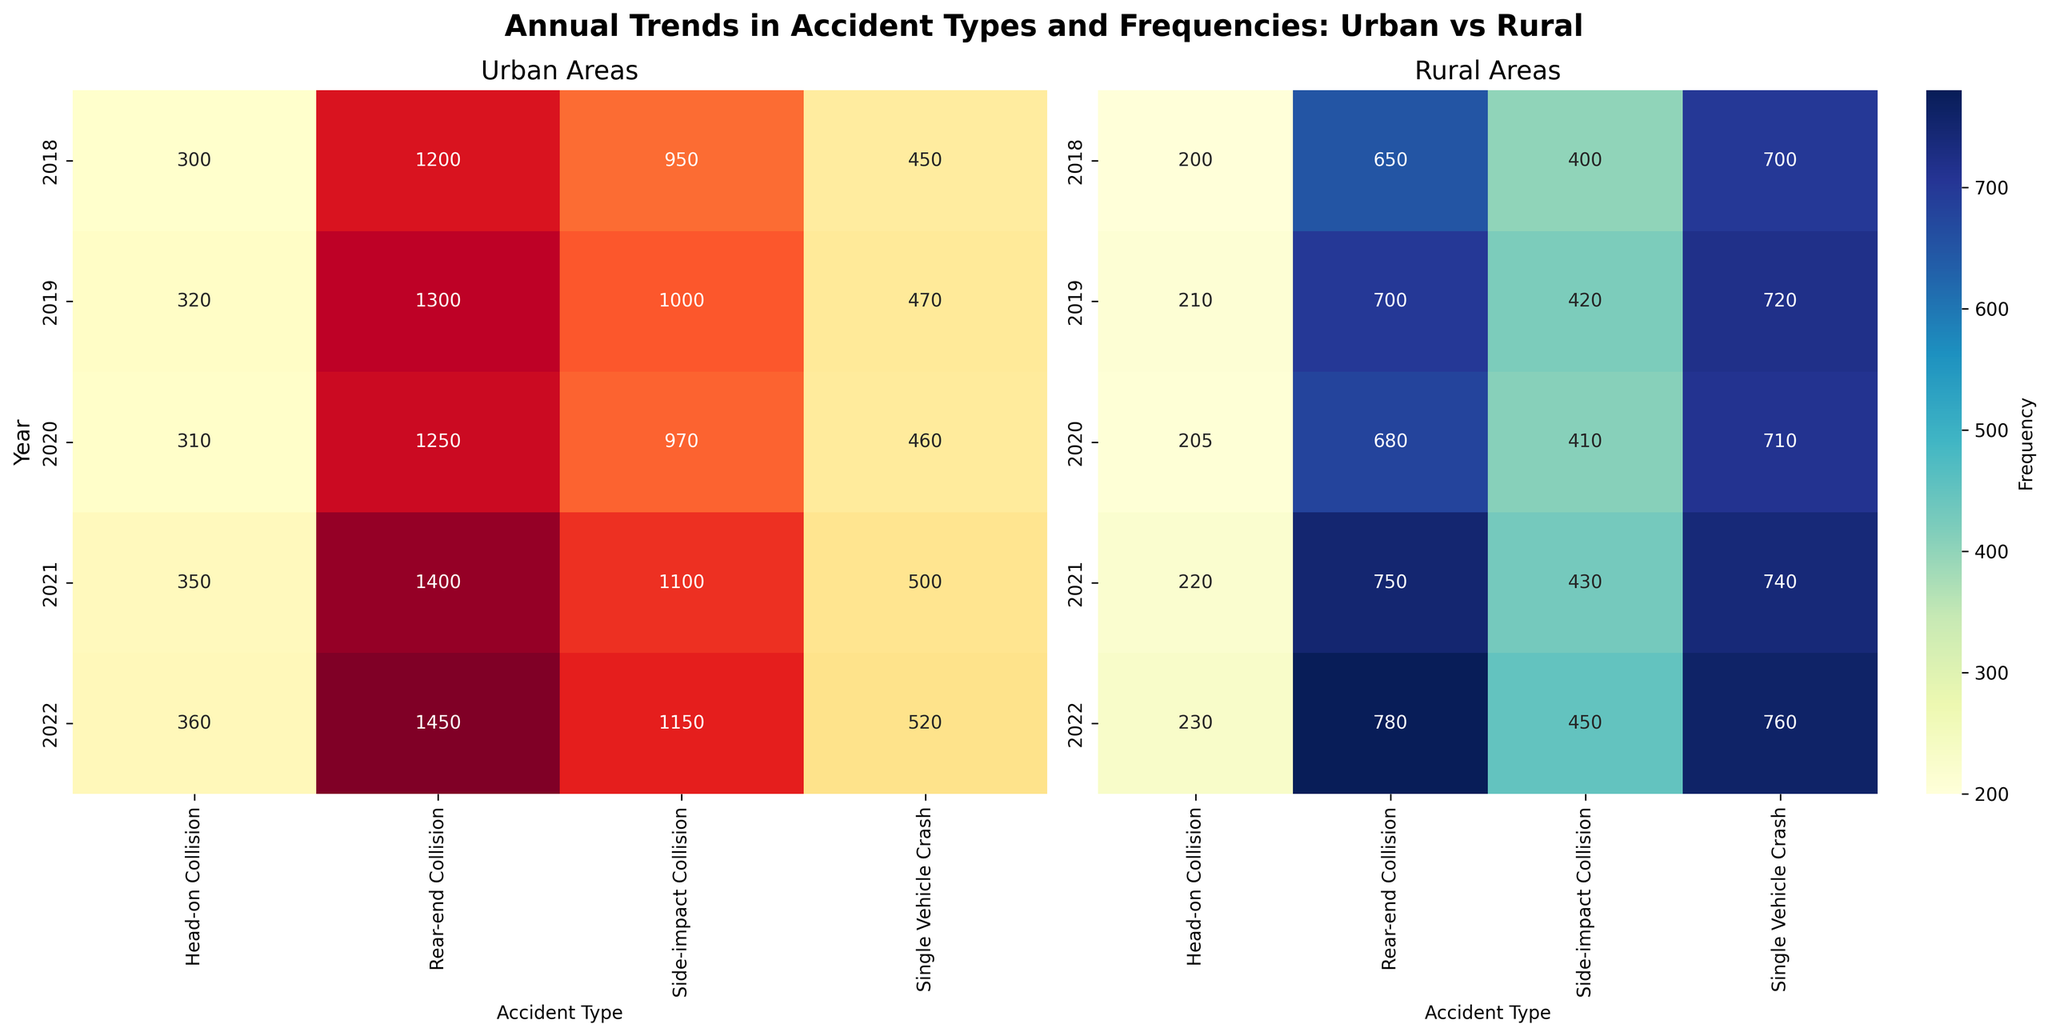How many types of accidents are reported for the year 2018 in rural areas? Look at the 'Rural Areas' heatmap under the year 2018, then count the number of accident types listed.
Answer: 4 Which type of accident had the highest frequency in urban areas in 2022? Look at the 'Urban Areas' heatmap under the year 2022 and find the highest value. The corresponding accident type is 'Rear-end Collision', with a frequency of 1450.
Answer: Rear-end Collision What is the total frequency of all accidents in rural areas in 2021? Check the 'Rural Areas' heatmap under the year 2021, then sum the frequency values for all accident types: 750 + 430 + 220 + 740 = 2140.
Answer: 2140 How does the frequency of side-impact collisions in urban areas compare between 2020 and 2022? Check the frequency of side-impact collisions for the 'Urban Areas' heatmap in the years 2020 and 2022. For 2020, it is 970, and for 2022, it is 1150.
Answer: Increased Which collision type experienced the least frequency in both urban and rural areas in 2020? Look at both heatmaps for 2020 and identify the lowest value for each. In urban areas, it is 'Head-on Collision' with 310, and in rural areas, it's also 'Head-on Collision' with 205. Hence, 'Head-on Collision' is the least frequent.
Answer: Head-on Collision Is there a trend in the frequency of single-vehicle crashes in rural areas from 2018 to 2022? Assess the 'Rural Areas' heatmap starting from 2018 up to 2022. Moving from 700 in 2018 to 720 in 2019, 710 in 2020, 740 in 2021, and 760 in 2022, there is an increasing trend.
Answer: Increasing What was the year with the highest overall frequency of rear-end collisions in urban areas? Look at the 'Urban Areas' heatmap for the frequency of rear-end collisions for each year. The highest value is 1450 in 2022.
Answer: 2022 What is the difference in frequency of side-impact collisions between urban and rural areas in 2021? Look at the 'Urban Areas' and 'Rural Areas' heatmaps for 2021 and find the frequencies of side-impact collisions: 1100 vs 430. Subtract rural frequency from urban frequency: 1100 - 430 = 670.
Answer: 670 